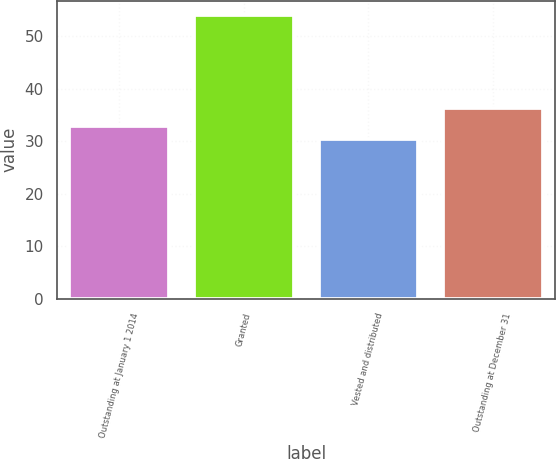Convert chart. <chart><loc_0><loc_0><loc_500><loc_500><bar_chart><fcel>Outstanding at January 1 2014<fcel>Granted<fcel>Vested and distributed<fcel>Outstanding at December 31<nl><fcel>32.88<fcel>54.06<fcel>30.53<fcel>36.35<nl></chart> 